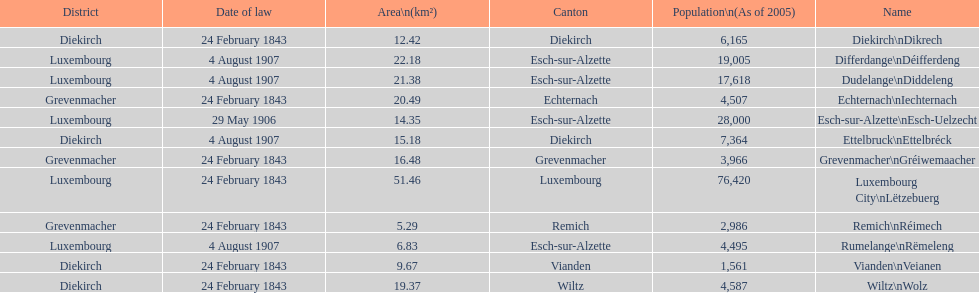How many luxembourg cities had a date of law of feb 24, 1843? 7. 